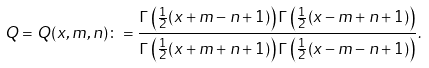<formula> <loc_0><loc_0><loc_500><loc_500>Q = Q ( x , m , n ) \colon = \frac { \Gamma \left ( \frac { 1 } { 2 } ( x + m - n + 1 ) \right ) \Gamma \left ( \frac { 1 } { 2 } ( x - m + n + 1 ) \right ) } { \Gamma \left ( \frac { 1 } { 2 } ( x + m + n + 1 ) \right ) \Gamma \left ( \frac { 1 } { 2 } ( x - m - n + 1 ) \right ) } .</formula> 